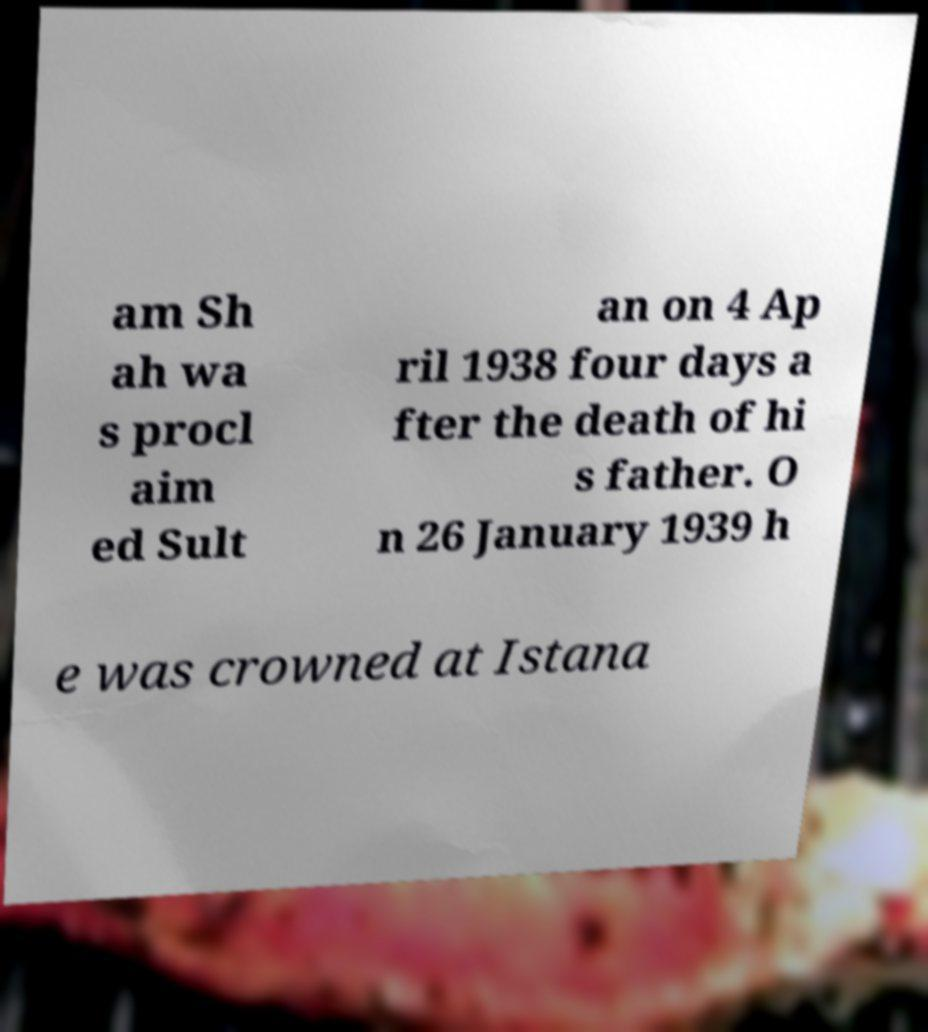There's text embedded in this image that I need extracted. Can you transcribe it verbatim? am Sh ah wa s procl aim ed Sult an on 4 Ap ril 1938 four days a fter the death of hi s father. O n 26 January 1939 h e was crowned at Istana 